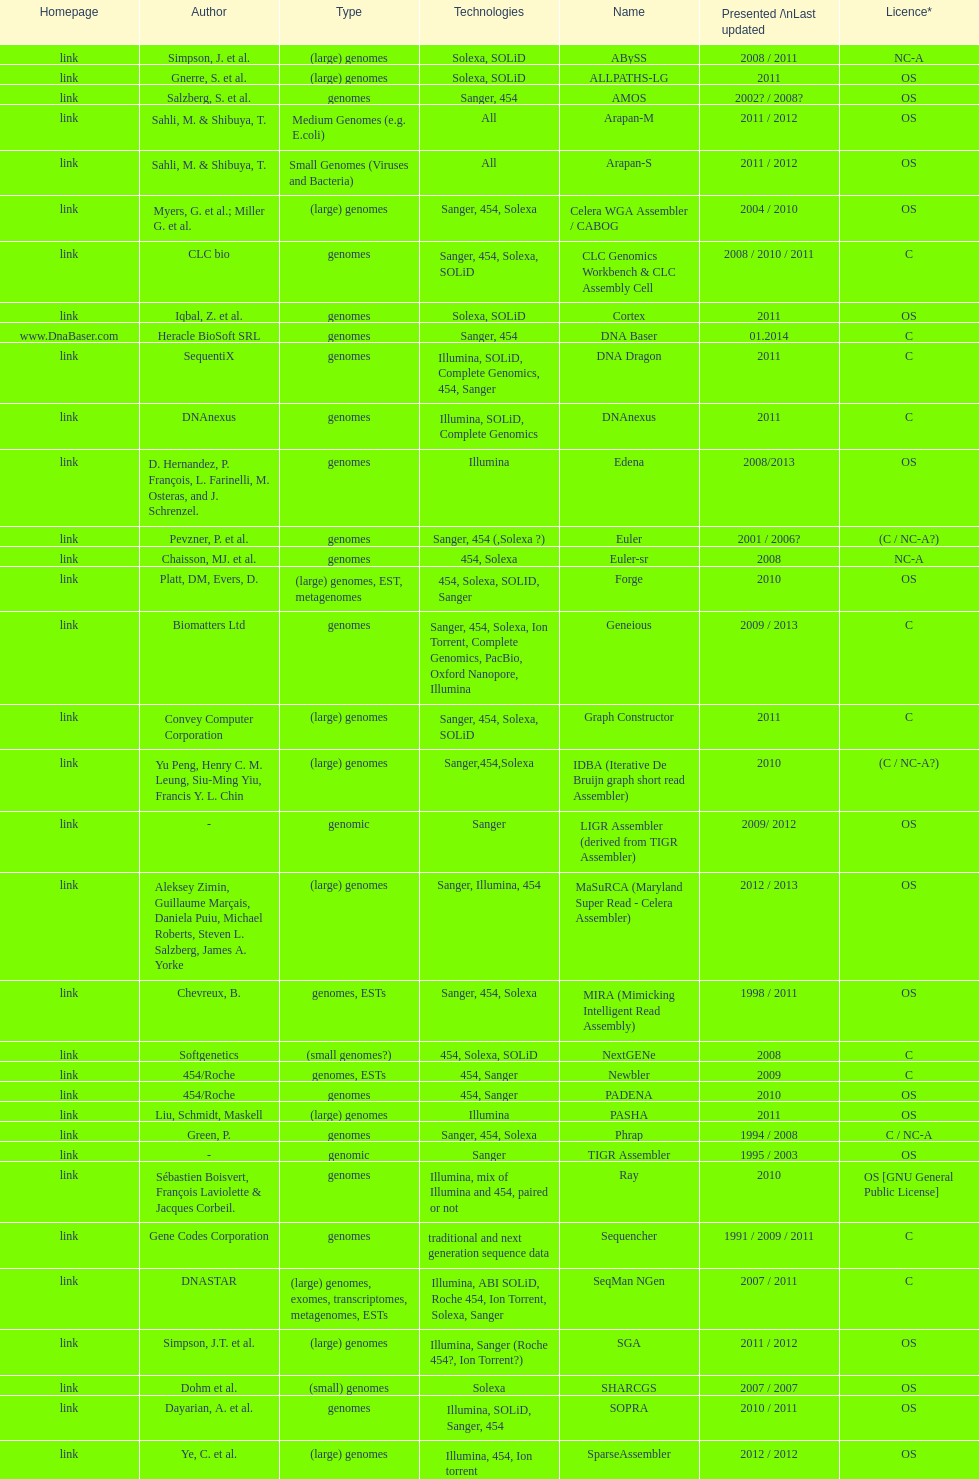When was the velvet last updated? 2009. 